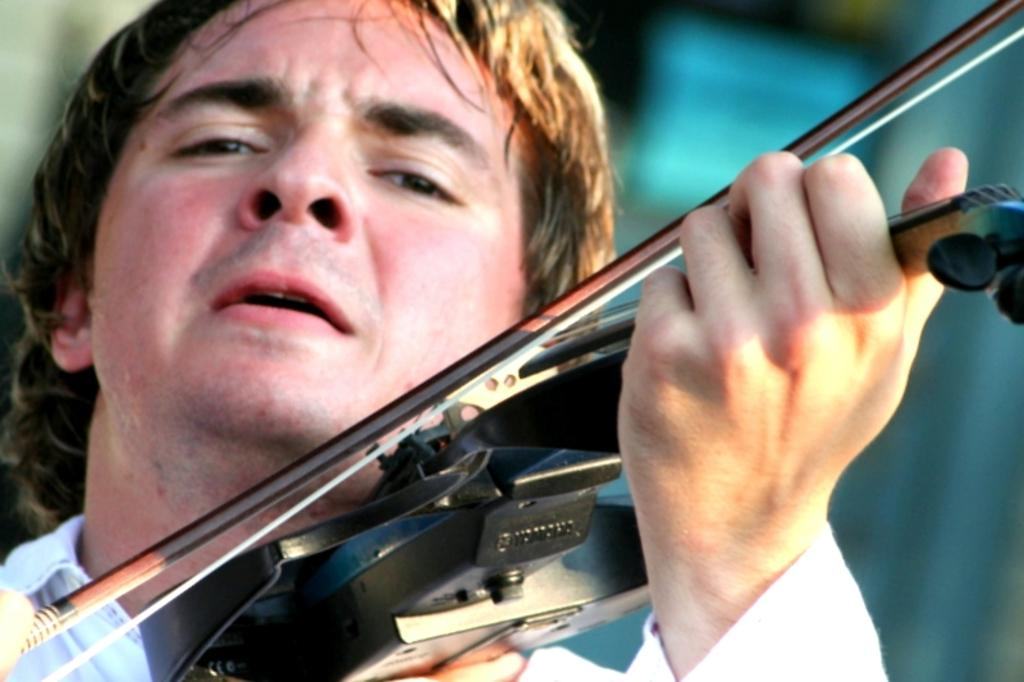What is the main subject of the image? There is a man in the image. What is the man doing in the image? The man is playing the violin. What type of receipt can be seen in the image? There is no receipt present in the image. What kind of trade agreement is being discussed in the image? There is no trade agreement or discussion present in the image; it features a man playing the violin. 